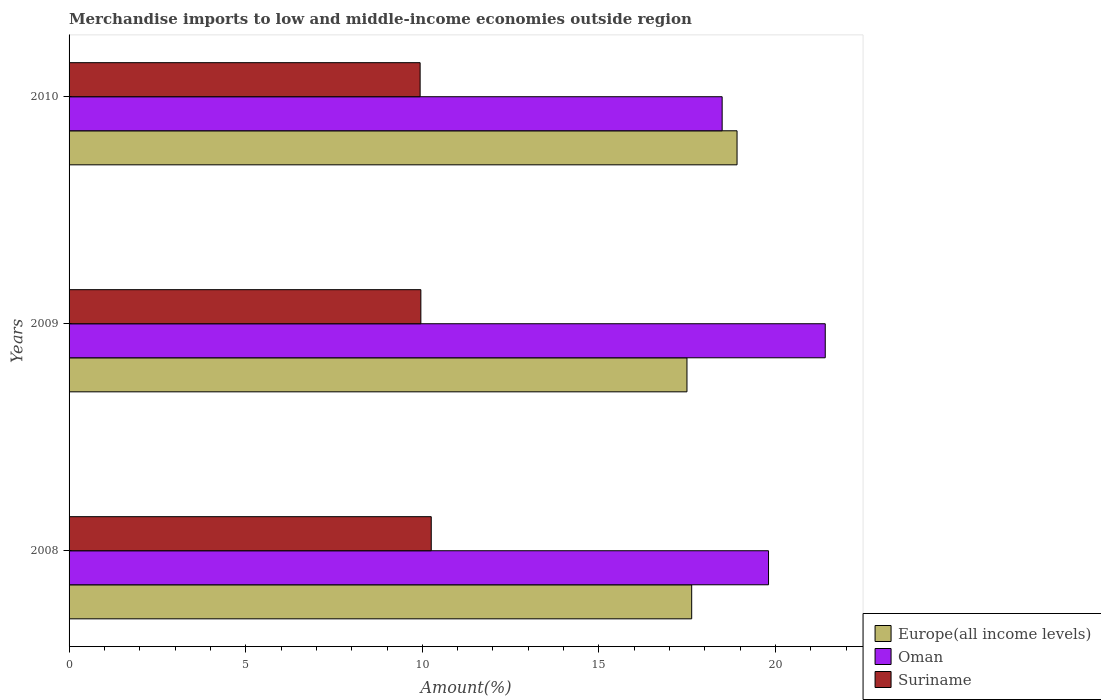How many different coloured bars are there?
Give a very brief answer. 3. How many groups of bars are there?
Offer a terse response. 3. How many bars are there on the 2nd tick from the top?
Make the answer very short. 3. In how many cases, is the number of bars for a given year not equal to the number of legend labels?
Offer a very short reply. 0. What is the percentage of amount earned from merchandise imports in Suriname in 2010?
Offer a very short reply. 9.94. Across all years, what is the maximum percentage of amount earned from merchandise imports in Suriname?
Keep it short and to the point. 10.25. Across all years, what is the minimum percentage of amount earned from merchandise imports in Europe(all income levels)?
Offer a terse response. 17.49. In which year was the percentage of amount earned from merchandise imports in Oman maximum?
Your answer should be compact. 2009. In which year was the percentage of amount earned from merchandise imports in Europe(all income levels) minimum?
Offer a very short reply. 2009. What is the total percentage of amount earned from merchandise imports in Oman in the graph?
Your response must be concise. 59.69. What is the difference between the percentage of amount earned from merchandise imports in Oman in 2008 and that in 2009?
Give a very brief answer. -1.61. What is the difference between the percentage of amount earned from merchandise imports in Suriname in 2010 and the percentage of amount earned from merchandise imports in Oman in 2008?
Provide a short and direct response. -9.86. What is the average percentage of amount earned from merchandise imports in Oman per year?
Give a very brief answer. 19.9. In the year 2008, what is the difference between the percentage of amount earned from merchandise imports in Suriname and percentage of amount earned from merchandise imports in Europe(all income levels)?
Offer a terse response. -7.37. What is the ratio of the percentage of amount earned from merchandise imports in Suriname in 2008 to that in 2010?
Offer a terse response. 1.03. What is the difference between the highest and the second highest percentage of amount earned from merchandise imports in Suriname?
Provide a succinct answer. 0.29. What is the difference between the highest and the lowest percentage of amount earned from merchandise imports in Oman?
Give a very brief answer. 2.92. What does the 3rd bar from the top in 2010 represents?
Your response must be concise. Europe(all income levels). What does the 1st bar from the bottom in 2008 represents?
Your answer should be very brief. Europe(all income levels). How many bars are there?
Keep it short and to the point. 9. What is the difference between two consecutive major ticks on the X-axis?
Offer a terse response. 5. Are the values on the major ticks of X-axis written in scientific E-notation?
Make the answer very short. No. Does the graph contain any zero values?
Offer a terse response. No. Does the graph contain grids?
Make the answer very short. No. What is the title of the graph?
Your answer should be very brief. Merchandise imports to low and middle-income economies outside region. What is the label or title of the X-axis?
Give a very brief answer. Amount(%). What is the Amount(%) of Europe(all income levels) in 2008?
Your response must be concise. 17.62. What is the Amount(%) of Oman in 2008?
Your answer should be compact. 19.8. What is the Amount(%) of Suriname in 2008?
Provide a short and direct response. 10.25. What is the Amount(%) in Europe(all income levels) in 2009?
Give a very brief answer. 17.49. What is the Amount(%) of Oman in 2009?
Give a very brief answer. 21.41. What is the Amount(%) in Suriname in 2009?
Offer a terse response. 9.96. What is the Amount(%) of Europe(all income levels) in 2010?
Your response must be concise. 18.91. What is the Amount(%) in Oman in 2010?
Keep it short and to the point. 18.49. What is the Amount(%) of Suriname in 2010?
Make the answer very short. 9.94. Across all years, what is the maximum Amount(%) of Europe(all income levels)?
Your response must be concise. 18.91. Across all years, what is the maximum Amount(%) of Oman?
Give a very brief answer. 21.41. Across all years, what is the maximum Amount(%) of Suriname?
Provide a short and direct response. 10.25. Across all years, what is the minimum Amount(%) of Europe(all income levels)?
Your response must be concise. 17.49. Across all years, what is the minimum Amount(%) in Oman?
Your answer should be very brief. 18.49. Across all years, what is the minimum Amount(%) in Suriname?
Your answer should be compact. 9.94. What is the total Amount(%) in Europe(all income levels) in the graph?
Ensure brevity in your answer.  54.02. What is the total Amount(%) of Oman in the graph?
Give a very brief answer. 59.69. What is the total Amount(%) of Suriname in the graph?
Offer a terse response. 30.15. What is the difference between the Amount(%) of Europe(all income levels) in 2008 and that in 2009?
Offer a very short reply. 0.13. What is the difference between the Amount(%) of Oman in 2008 and that in 2009?
Offer a very short reply. -1.61. What is the difference between the Amount(%) in Suriname in 2008 and that in 2009?
Make the answer very short. 0.29. What is the difference between the Amount(%) of Europe(all income levels) in 2008 and that in 2010?
Provide a succinct answer. -1.28. What is the difference between the Amount(%) in Oman in 2008 and that in 2010?
Provide a short and direct response. 1.31. What is the difference between the Amount(%) in Suriname in 2008 and that in 2010?
Keep it short and to the point. 0.31. What is the difference between the Amount(%) of Europe(all income levels) in 2009 and that in 2010?
Make the answer very short. -1.42. What is the difference between the Amount(%) of Oman in 2009 and that in 2010?
Provide a short and direct response. 2.92. What is the difference between the Amount(%) of Suriname in 2009 and that in 2010?
Your answer should be very brief. 0.02. What is the difference between the Amount(%) of Europe(all income levels) in 2008 and the Amount(%) of Oman in 2009?
Give a very brief answer. -3.78. What is the difference between the Amount(%) in Europe(all income levels) in 2008 and the Amount(%) in Suriname in 2009?
Give a very brief answer. 7.67. What is the difference between the Amount(%) in Oman in 2008 and the Amount(%) in Suriname in 2009?
Offer a terse response. 9.84. What is the difference between the Amount(%) in Europe(all income levels) in 2008 and the Amount(%) in Oman in 2010?
Make the answer very short. -0.86. What is the difference between the Amount(%) in Europe(all income levels) in 2008 and the Amount(%) in Suriname in 2010?
Make the answer very short. 7.69. What is the difference between the Amount(%) of Oman in 2008 and the Amount(%) of Suriname in 2010?
Offer a very short reply. 9.86. What is the difference between the Amount(%) in Europe(all income levels) in 2009 and the Amount(%) in Oman in 2010?
Your response must be concise. -1. What is the difference between the Amount(%) in Europe(all income levels) in 2009 and the Amount(%) in Suriname in 2010?
Provide a succinct answer. 7.55. What is the difference between the Amount(%) of Oman in 2009 and the Amount(%) of Suriname in 2010?
Make the answer very short. 11.47. What is the average Amount(%) in Europe(all income levels) per year?
Offer a very short reply. 18.01. What is the average Amount(%) of Oman per year?
Your answer should be compact. 19.9. What is the average Amount(%) of Suriname per year?
Provide a succinct answer. 10.05. In the year 2008, what is the difference between the Amount(%) in Europe(all income levels) and Amount(%) in Oman?
Offer a terse response. -2.18. In the year 2008, what is the difference between the Amount(%) of Europe(all income levels) and Amount(%) of Suriname?
Give a very brief answer. 7.37. In the year 2008, what is the difference between the Amount(%) of Oman and Amount(%) of Suriname?
Provide a short and direct response. 9.55. In the year 2009, what is the difference between the Amount(%) of Europe(all income levels) and Amount(%) of Oman?
Ensure brevity in your answer.  -3.91. In the year 2009, what is the difference between the Amount(%) of Europe(all income levels) and Amount(%) of Suriname?
Your answer should be compact. 7.53. In the year 2009, what is the difference between the Amount(%) in Oman and Amount(%) in Suriname?
Your answer should be compact. 11.45. In the year 2010, what is the difference between the Amount(%) in Europe(all income levels) and Amount(%) in Oman?
Your response must be concise. 0.42. In the year 2010, what is the difference between the Amount(%) of Europe(all income levels) and Amount(%) of Suriname?
Your answer should be compact. 8.97. In the year 2010, what is the difference between the Amount(%) of Oman and Amount(%) of Suriname?
Your answer should be very brief. 8.55. What is the ratio of the Amount(%) in Europe(all income levels) in 2008 to that in 2009?
Provide a short and direct response. 1.01. What is the ratio of the Amount(%) in Oman in 2008 to that in 2009?
Make the answer very short. 0.93. What is the ratio of the Amount(%) of Suriname in 2008 to that in 2009?
Your answer should be very brief. 1.03. What is the ratio of the Amount(%) in Europe(all income levels) in 2008 to that in 2010?
Offer a terse response. 0.93. What is the ratio of the Amount(%) of Oman in 2008 to that in 2010?
Provide a short and direct response. 1.07. What is the ratio of the Amount(%) in Suriname in 2008 to that in 2010?
Keep it short and to the point. 1.03. What is the ratio of the Amount(%) in Europe(all income levels) in 2009 to that in 2010?
Your answer should be very brief. 0.93. What is the ratio of the Amount(%) in Oman in 2009 to that in 2010?
Give a very brief answer. 1.16. What is the ratio of the Amount(%) in Suriname in 2009 to that in 2010?
Your answer should be compact. 1. What is the difference between the highest and the second highest Amount(%) in Europe(all income levels)?
Ensure brevity in your answer.  1.28. What is the difference between the highest and the second highest Amount(%) of Oman?
Give a very brief answer. 1.61. What is the difference between the highest and the second highest Amount(%) of Suriname?
Give a very brief answer. 0.29. What is the difference between the highest and the lowest Amount(%) of Europe(all income levels)?
Provide a short and direct response. 1.42. What is the difference between the highest and the lowest Amount(%) in Oman?
Your response must be concise. 2.92. What is the difference between the highest and the lowest Amount(%) of Suriname?
Your answer should be very brief. 0.31. 